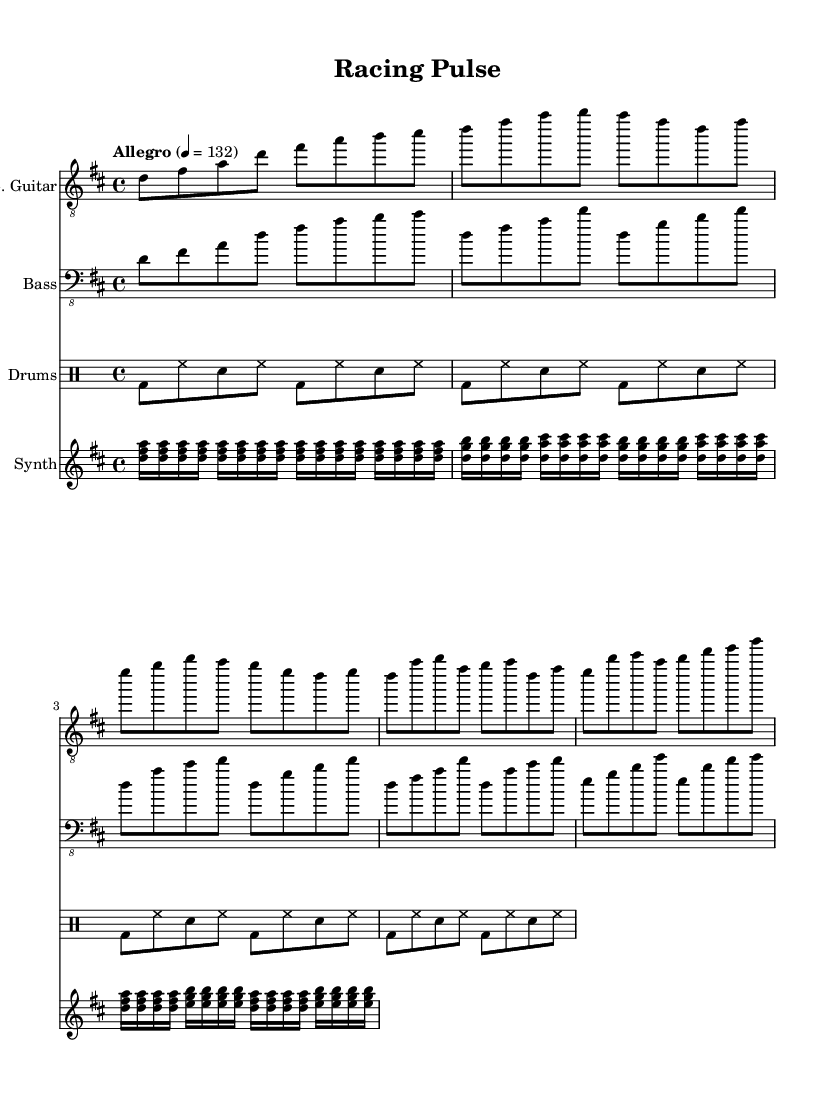What is the key signature of this music? The key signature is indicated by the sharps or flats at the beginning of the staff. In this case, there are two sharps, which correspond to F# and C#. Therefore, the key signature is D major.
Answer: D major What is the time signature of this music? The time signature is provided at the beginning of the score and is depicted as a fraction. Here, the fraction shows a 4 on top and a 4 on the bottom, indicating that there are four beats in each measure.
Answer: 4/4 What is the tempo marking for this piece? The tempo marking is usually found at the beginning of the score and indicates the speed at which the music should be played. The marking here indicates "Allegro" at a rate of quarter note equals 132 beats per minute.
Answer: Allegro 4 = 132 How many measures are present in the electric guitar part? To find the number of measures, you count the vertical bar lines in the electric guitar part. Each set of bars represents one measure. In this score, there are a total of 8 measures in the electric guitar section.
Answer: 8 What is the primary rhythmic figure used in the drums part? The drum part shows a recurring pattern that consists of bass drum, hi-hat, and snare drum. By observing the notation, the main rhythm is a traditional rock beat highlighted by the percussion notation.
Answer: Basic rock beat What instrument plays the arpeggiated pattern? The arpeggiated pattern is typically characterized by broken chords played in succession. In this score, the synth part is the one playing the arpeggiated pattern using notes marked as 16th notes.
Answer: Synth How does the bass guitar complement the electric guitar in this piece? By analyzing both parts, the bass guitar plays a foundational rhythm and harmonizes with the electric guitar by following the root notes and adding depth to the overall sound. This creates a cohesive blend that supports the guitar melody.
Answer: Harmonizes 